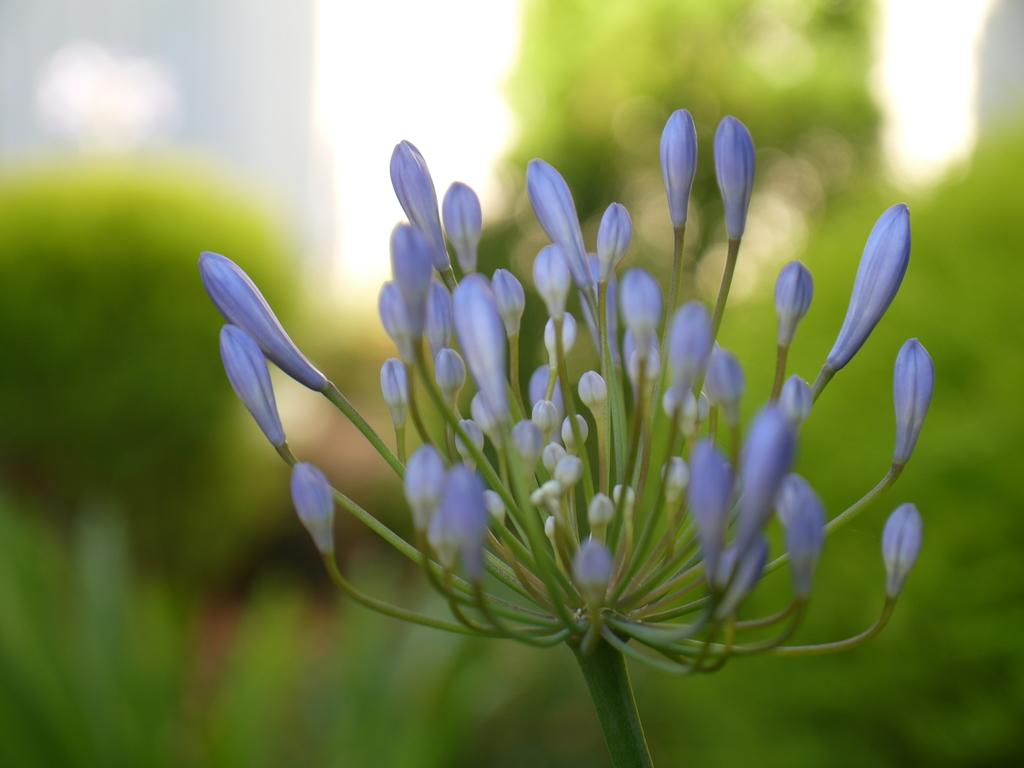Where was the image taken? The image was taken outdoors. What can be seen in the background of the image? There are trees and plants in the background of the image. What is the main subject of the image? There is a plant with buds in the middle of the image. What type of powder is being used to force the buds to open in the image? There is no powder or force being used to open the buds in the image; the plant is shown naturally with buds. 